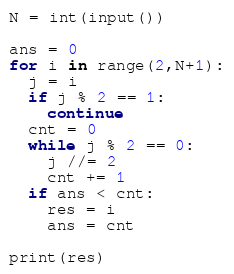<code> <loc_0><loc_0><loc_500><loc_500><_Python_>N = int(input())

ans = 0
for i in range(2,N+1):
  j = i
  if j % 2 == 1:
    continue
  cnt = 0
  while j % 2 == 0:
    j //= 2
    cnt += 1
  if ans < cnt:
    res = i
    ans = cnt
  
print(res)</code> 